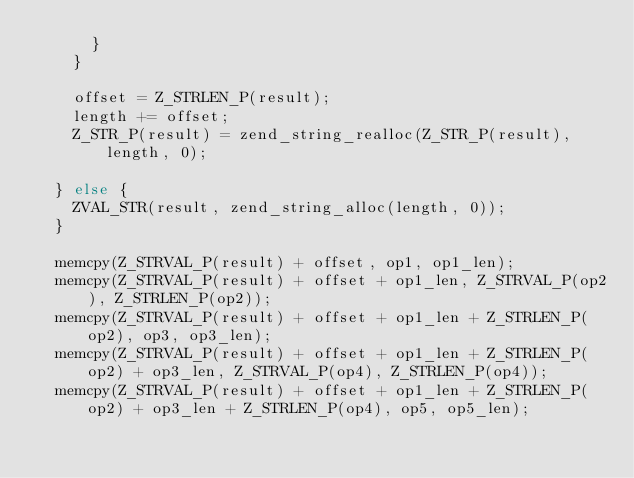<code> <loc_0><loc_0><loc_500><loc_500><_C_>			}
		}

		offset = Z_STRLEN_P(result);
		length += offset;
		Z_STR_P(result) = zend_string_realloc(Z_STR_P(result), length, 0);

	} else {
		ZVAL_STR(result, zend_string_alloc(length, 0));
	}

	memcpy(Z_STRVAL_P(result) + offset, op1, op1_len);
	memcpy(Z_STRVAL_P(result) + offset + op1_len, Z_STRVAL_P(op2), Z_STRLEN_P(op2));
	memcpy(Z_STRVAL_P(result) + offset + op1_len + Z_STRLEN_P(op2), op3, op3_len);
	memcpy(Z_STRVAL_P(result) + offset + op1_len + Z_STRLEN_P(op2) + op3_len, Z_STRVAL_P(op4), Z_STRLEN_P(op4));
	memcpy(Z_STRVAL_P(result) + offset + op1_len + Z_STRLEN_P(op2) + op3_len + Z_STRLEN_P(op4), op5, op5_len);</code> 